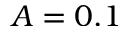Convert formula to latex. <formula><loc_0><loc_0><loc_500><loc_500>A = 0 . 1</formula> 